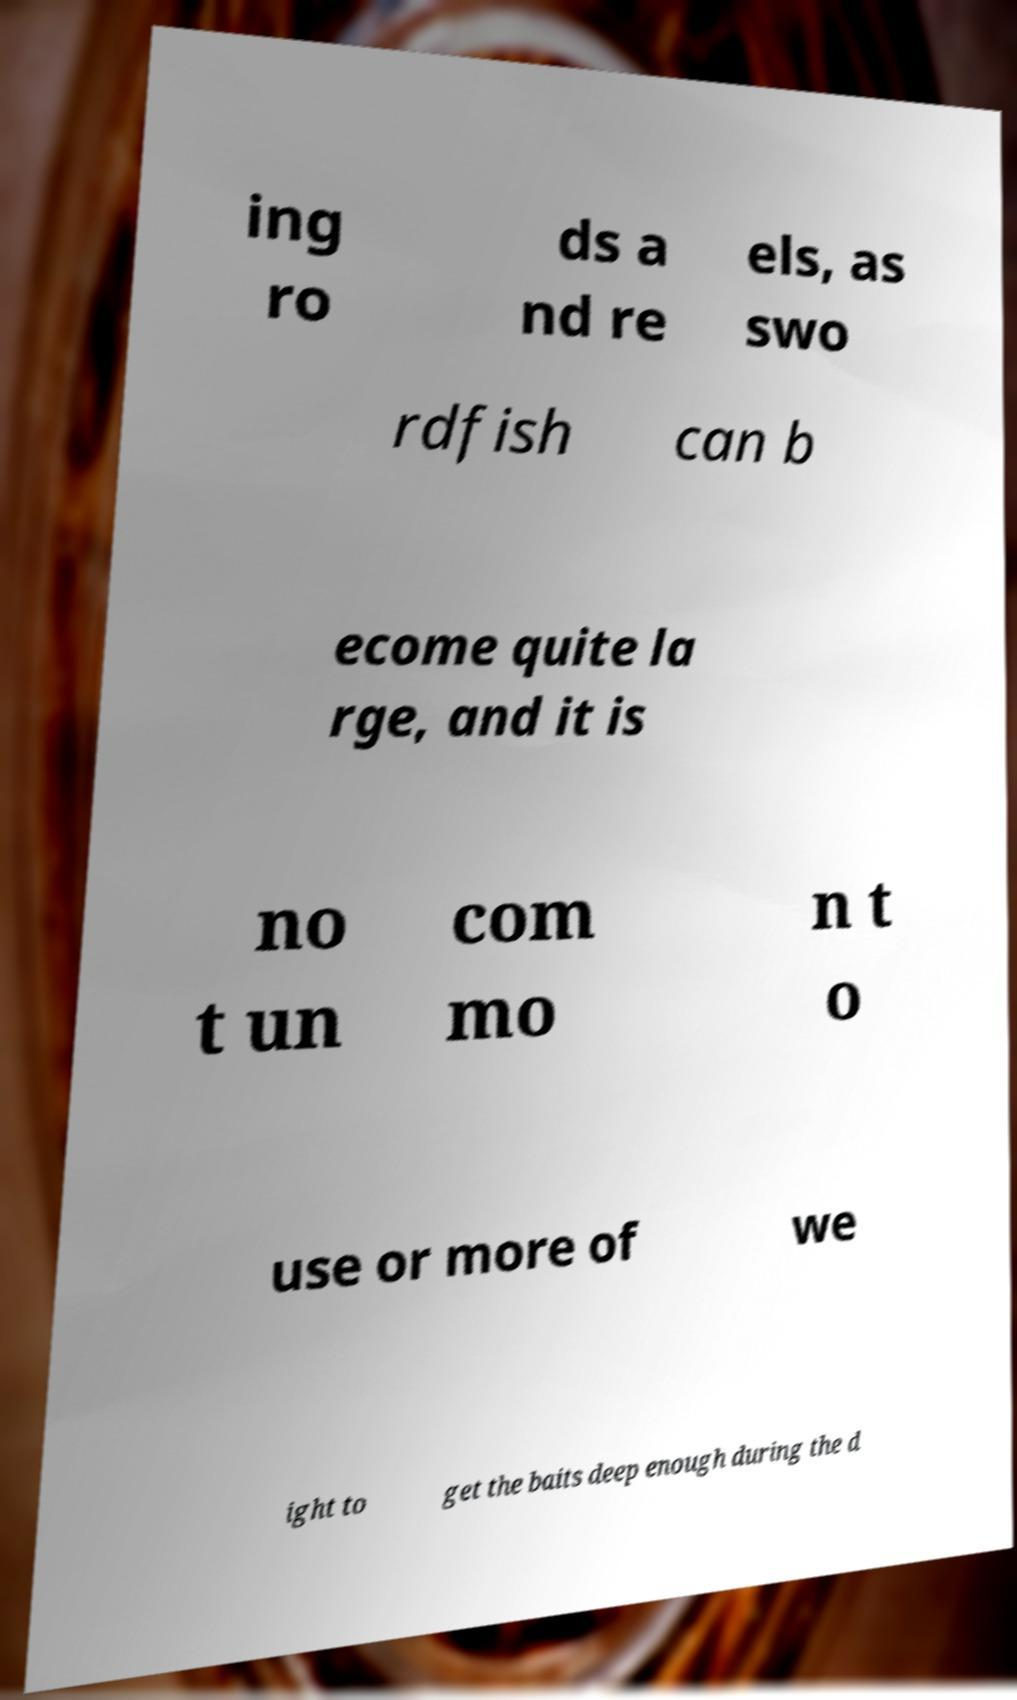For documentation purposes, I need the text within this image transcribed. Could you provide that? ing ro ds a nd re els, as swo rdfish can b ecome quite la rge, and it is no t un com mo n t o use or more of we ight to get the baits deep enough during the d 